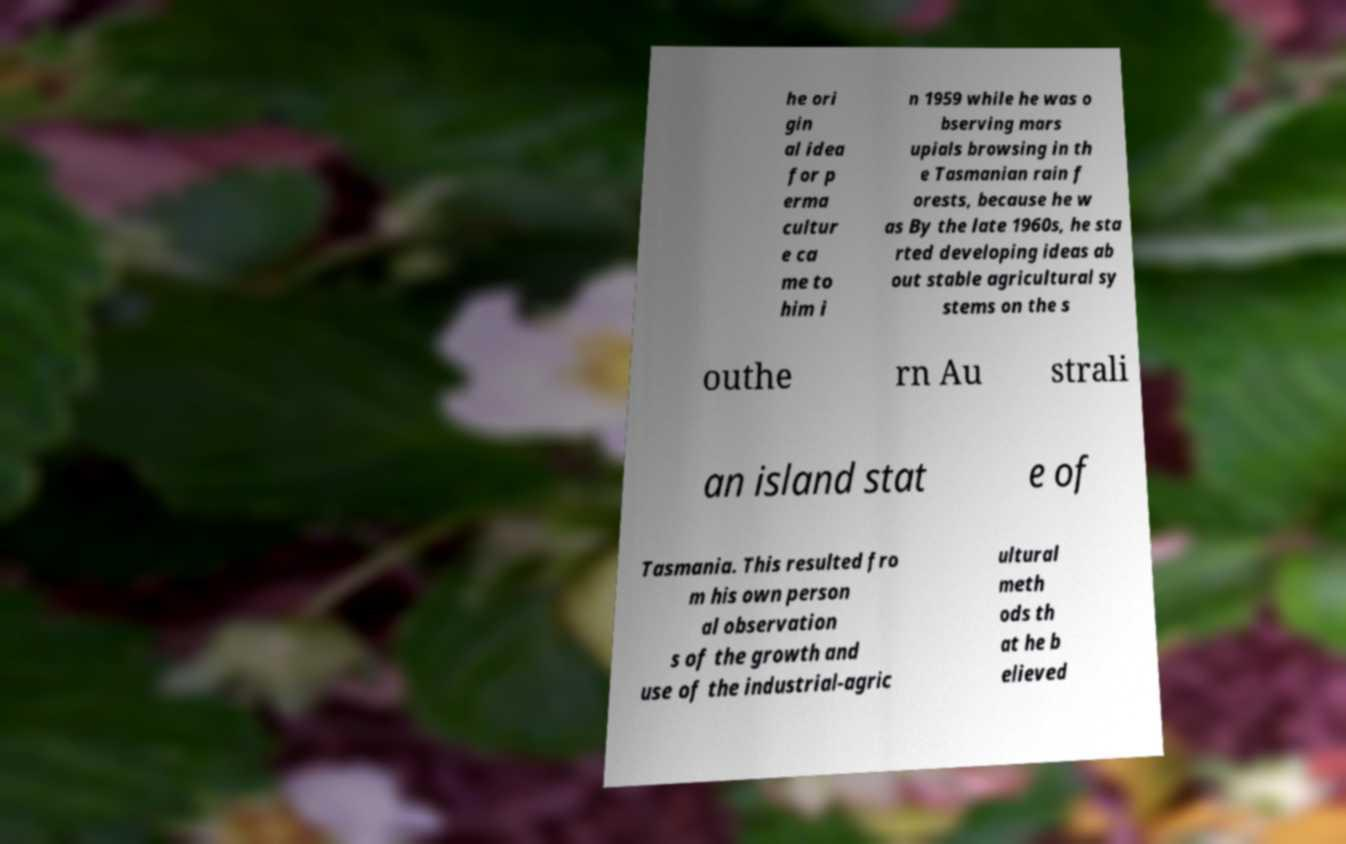Please read and relay the text visible in this image. What does it say? he ori gin al idea for p erma cultur e ca me to him i n 1959 while he was o bserving mars upials browsing in th e Tasmanian rain f orests, because he w as By the late 1960s, he sta rted developing ideas ab out stable agricultural sy stems on the s outhe rn Au strali an island stat e of Tasmania. This resulted fro m his own person al observation s of the growth and use of the industrial-agric ultural meth ods th at he b elieved 